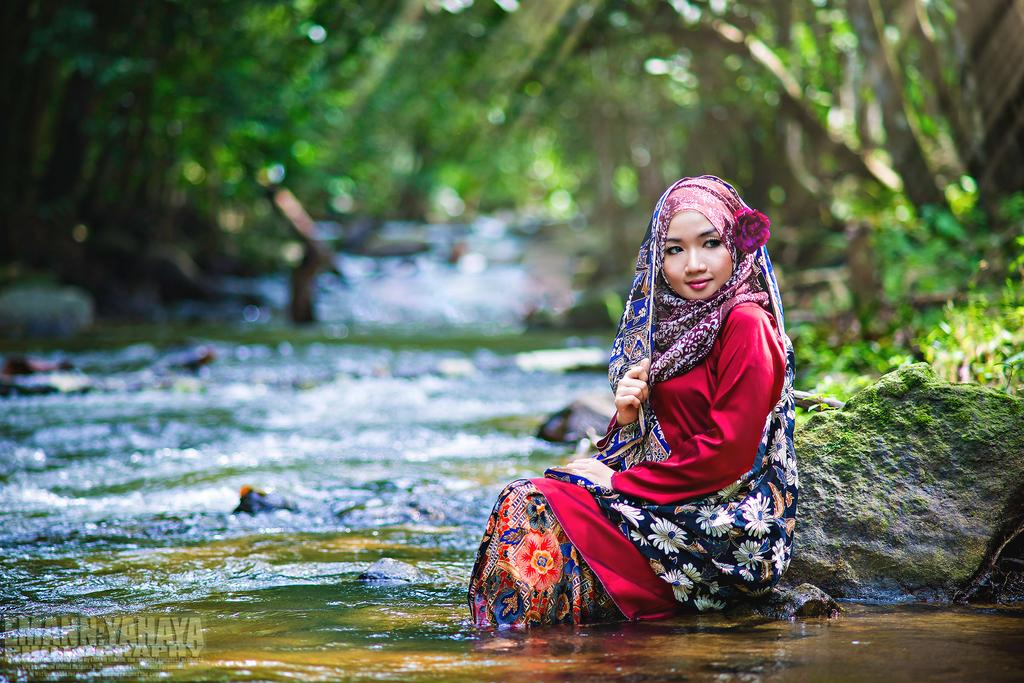What is the girl doing in the image? The girl is sitting on the rocks in the image. What is the girl's position in relation to the water? The girl's feet are in the water. What can be seen behind the girl? There is a lake and trees visible behind the girl. Is there any text in the image? Yes, there is some text at the bottom of the image. What type of trouble does the girl's thumb get into in the image? There is no mention of the girl's thumb or any trouble in the image. 